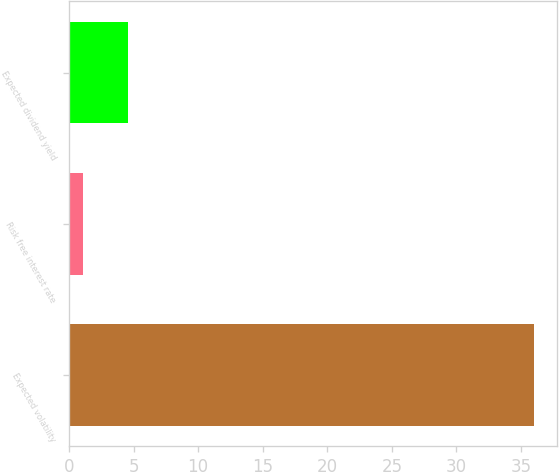Convert chart. <chart><loc_0><loc_0><loc_500><loc_500><bar_chart><fcel>Expected volatility<fcel>Risk free interest rate<fcel>Expected dividend yield<nl><fcel>36<fcel>1.05<fcel>4.55<nl></chart> 